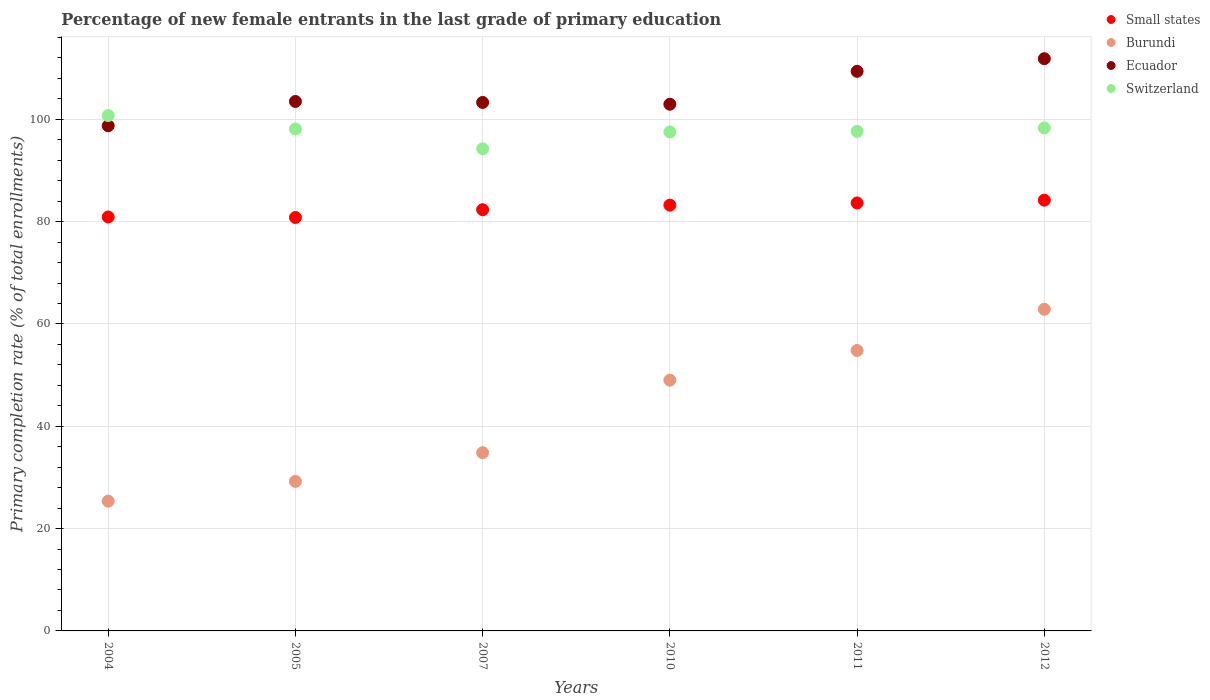How many different coloured dotlines are there?
Your answer should be very brief. 4. Is the number of dotlines equal to the number of legend labels?
Keep it short and to the point. Yes. What is the percentage of new female entrants in Ecuador in 2010?
Your answer should be very brief. 102.95. Across all years, what is the maximum percentage of new female entrants in Small states?
Your answer should be compact. 84.2. Across all years, what is the minimum percentage of new female entrants in Switzerland?
Make the answer very short. 94.25. In which year was the percentage of new female entrants in Ecuador maximum?
Offer a very short reply. 2012. What is the total percentage of new female entrants in Switzerland in the graph?
Offer a very short reply. 586.6. What is the difference between the percentage of new female entrants in Switzerland in 2004 and that in 2012?
Provide a short and direct response. 2.4. What is the difference between the percentage of new female entrants in Burundi in 2004 and the percentage of new female entrants in Switzerland in 2007?
Offer a terse response. -68.88. What is the average percentage of new female entrants in Ecuador per year?
Your answer should be very brief. 104.95. In the year 2012, what is the difference between the percentage of new female entrants in Small states and percentage of new female entrants in Switzerland?
Provide a succinct answer. -14.13. In how many years, is the percentage of new female entrants in Burundi greater than 112 %?
Make the answer very short. 0. What is the ratio of the percentage of new female entrants in Ecuador in 2004 to that in 2007?
Your response must be concise. 0.96. Is the percentage of new female entrants in Small states in 2011 less than that in 2012?
Offer a terse response. Yes. Is the difference between the percentage of new female entrants in Small states in 2011 and 2012 greater than the difference between the percentage of new female entrants in Switzerland in 2011 and 2012?
Provide a succinct answer. Yes. What is the difference between the highest and the second highest percentage of new female entrants in Burundi?
Keep it short and to the point. 8.06. What is the difference between the highest and the lowest percentage of new female entrants in Ecuador?
Offer a terse response. 13.11. In how many years, is the percentage of new female entrants in Small states greater than the average percentage of new female entrants in Small states taken over all years?
Keep it short and to the point. 3. Is the sum of the percentage of new female entrants in Switzerland in 2004 and 2011 greater than the maximum percentage of new female entrants in Ecuador across all years?
Provide a succinct answer. Yes. Is it the case that in every year, the sum of the percentage of new female entrants in Switzerland and percentage of new female entrants in Ecuador  is greater than the sum of percentage of new female entrants in Small states and percentage of new female entrants in Burundi?
Provide a succinct answer. Yes. Is it the case that in every year, the sum of the percentage of new female entrants in Ecuador and percentage of new female entrants in Small states  is greater than the percentage of new female entrants in Switzerland?
Offer a very short reply. Yes. Does the percentage of new female entrants in Small states monotonically increase over the years?
Your response must be concise. No. Is the percentage of new female entrants in Ecuador strictly less than the percentage of new female entrants in Burundi over the years?
Give a very brief answer. No. How many dotlines are there?
Your answer should be very brief. 4. How many years are there in the graph?
Provide a short and direct response. 6. How many legend labels are there?
Your response must be concise. 4. How are the legend labels stacked?
Provide a succinct answer. Vertical. What is the title of the graph?
Keep it short and to the point. Percentage of new female entrants in the last grade of primary education. What is the label or title of the X-axis?
Offer a very short reply. Years. What is the label or title of the Y-axis?
Provide a short and direct response. Primary completion rate (% of total enrollments). What is the Primary completion rate (% of total enrollments) in Small states in 2004?
Give a very brief answer. 80.91. What is the Primary completion rate (% of total enrollments) in Burundi in 2004?
Make the answer very short. 25.37. What is the Primary completion rate (% of total enrollments) in Ecuador in 2004?
Provide a short and direct response. 98.74. What is the Primary completion rate (% of total enrollments) of Switzerland in 2004?
Keep it short and to the point. 100.73. What is the Primary completion rate (% of total enrollments) in Small states in 2005?
Ensure brevity in your answer.  80.81. What is the Primary completion rate (% of total enrollments) of Burundi in 2005?
Your answer should be compact. 29.23. What is the Primary completion rate (% of total enrollments) in Ecuador in 2005?
Your answer should be very brief. 103.5. What is the Primary completion rate (% of total enrollments) of Switzerland in 2005?
Make the answer very short. 98.11. What is the Primary completion rate (% of total enrollments) of Small states in 2007?
Make the answer very short. 82.34. What is the Primary completion rate (% of total enrollments) in Burundi in 2007?
Provide a succinct answer. 34.84. What is the Primary completion rate (% of total enrollments) in Ecuador in 2007?
Your response must be concise. 103.3. What is the Primary completion rate (% of total enrollments) of Switzerland in 2007?
Offer a terse response. 94.25. What is the Primary completion rate (% of total enrollments) in Small states in 2010?
Keep it short and to the point. 83.23. What is the Primary completion rate (% of total enrollments) in Burundi in 2010?
Your answer should be very brief. 49.01. What is the Primary completion rate (% of total enrollments) in Ecuador in 2010?
Provide a succinct answer. 102.95. What is the Primary completion rate (% of total enrollments) in Switzerland in 2010?
Offer a very short reply. 97.54. What is the Primary completion rate (% of total enrollments) in Small states in 2011?
Offer a terse response. 83.66. What is the Primary completion rate (% of total enrollments) of Burundi in 2011?
Your response must be concise. 54.82. What is the Primary completion rate (% of total enrollments) of Ecuador in 2011?
Your answer should be very brief. 109.38. What is the Primary completion rate (% of total enrollments) of Switzerland in 2011?
Make the answer very short. 97.64. What is the Primary completion rate (% of total enrollments) in Small states in 2012?
Your answer should be very brief. 84.2. What is the Primary completion rate (% of total enrollments) of Burundi in 2012?
Keep it short and to the point. 62.88. What is the Primary completion rate (% of total enrollments) in Ecuador in 2012?
Offer a very short reply. 111.85. What is the Primary completion rate (% of total enrollments) in Switzerland in 2012?
Ensure brevity in your answer.  98.33. Across all years, what is the maximum Primary completion rate (% of total enrollments) in Small states?
Your answer should be compact. 84.2. Across all years, what is the maximum Primary completion rate (% of total enrollments) in Burundi?
Offer a very short reply. 62.88. Across all years, what is the maximum Primary completion rate (% of total enrollments) of Ecuador?
Make the answer very short. 111.85. Across all years, what is the maximum Primary completion rate (% of total enrollments) in Switzerland?
Offer a very short reply. 100.73. Across all years, what is the minimum Primary completion rate (% of total enrollments) of Small states?
Your answer should be compact. 80.81. Across all years, what is the minimum Primary completion rate (% of total enrollments) in Burundi?
Offer a terse response. 25.37. Across all years, what is the minimum Primary completion rate (% of total enrollments) of Ecuador?
Ensure brevity in your answer.  98.74. Across all years, what is the minimum Primary completion rate (% of total enrollments) in Switzerland?
Offer a very short reply. 94.25. What is the total Primary completion rate (% of total enrollments) of Small states in the graph?
Ensure brevity in your answer.  495.15. What is the total Primary completion rate (% of total enrollments) of Burundi in the graph?
Ensure brevity in your answer.  256.14. What is the total Primary completion rate (% of total enrollments) in Ecuador in the graph?
Ensure brevity in your answer.  629.73. What is the total Primary completion rate (% of total enrollments) of Switzerland in the graph?
Provide a succinct answer. 586.6. What is the difference between the Primary completion rate (% of total enrollments) of Small states in 2004 and that in 2005?
Provide a short and direct response. 0.1. What is the difference between the Primary completion rate (% of total enrollments) in Burundi in 2004 and that in 2005?
Provide a short and direct response. -3.87. What is the difference between the Primary completion rate (% of total enrollments) of Ecuador in 2004 and that in 2005?
Ensure brevity in your answer.  -4.75. What is the difference between the Primary completion rate (% of total enrollments) in Switzerland in 2004 and that in 2005?
Offer a terse response. 2.62. What is the difference between the Primary completion rate (% of total enrollments) of Small states in 2004 and that in 2007?
Provide a short and direct response. -1.42. What is the difference between the Primary completion rate (% of total enrollments) of Burundi in 2004 and that in 2007?
Offer a terse response. -9.47. What is the difference between the Primary completion rate (% of total enrollments) in Ecuador in 2004 and that in 2007?
Offer a very short reply. -4.56. What is the difference between the Primary completion rate (% of total enrollments) of Switzerland in 2004 and that in 2007?
Your response must be concise. 6.49. What is the difference between the Primary completion rate (% of total enrollments) of Small states in 2004 and that in 2010?
Ensure brevity in your answer.  -2.31. What is the difference between the Primary completion rate (% of total enrollments) of Burundi in 2004 and that in 2010?
Keep it short and to the point. -23.65. What is the difference between the Primary completion rate (% of total enrollments) in Ecuador in 2004 and that in 2010?
Your response must be concise. -4.21. What is the difference between the Primary completion rate (% of total enrollments) of Switzerland in 2004 and that in 2010?
Offer a terse response. 3.19. What is the difference between the Primary completion rate (% of total enrollments) in Small states in 2004 and that in 2011?
Your answer should be very brief. -2.74. What is the difference between the Primary completion rate (% of total enrollments) of Burundi in 2004 and that in 2011?
Make the answer very short. -29.45. What is the difference between the Primary completion rate (% of total enrollments) in Ecuador in 2004 and that in 2011?
Provide a short and direct response. -10.64. What is the difference between the Primary completion rate (% of total enrollments) of Switzerland in 2004 and that in 2011?
Keep it short and to the point. 3.09. What is the difference between the Primary completion rate (% of total enrollments) of Small states in 2004 and that in 2012?
Give a very brief answer. -3.29. What is the difference between the Primary completion rate (% of total enrollments) of Burundi in 2004 and that in 2012?
Provide a short and direct response. -37.51. What is the difference between the Primary completion rate (% of total enrollments) in Ecuador in 2004 and that in 2012?
Provide a succinct answer. -13.11. What is the difference between the Primary completion rate (% of total enrollments) in Switzerland in 2004 and that in 2012?
Offer a very short reply. 2.4. What is the difference between the Primary completion rate (% of total enrollments) in Small states in 2005 and that in 2007?
Your answer should be compact. -1.52. What is the difference between the Primary completion rate (% of total enrollments) in Burundi in 2005 and that in 2007?
Keep it short and to the point. -5.61. What is the difference between the Primary completion rate (% of total enrollments) of Ecuador in 2005 and that in 2007?
Offer a terse response. 0.19. What is the difference between the Primary completion rate (% of total enrollments) in Switzerland in 2005 and that in 2007?
Provide a succinct answer. 3.86. What is the difference between the Primary completion rate (% of total enrollments) of Small states in 2005 and that in 2010?
Give a very brief answer. -2.41. What is the difference between the Primary completion rate (% of total enrollments) in Burundi in 2005 and that in 2010?
Make the answer very short. -19.78. What is the difference between the Primary completion rate (% of total enrollments) of Ecuador in 2005 and that in 2010?
Provide a short and direct response. 0.54. What is the difference between the Primary completion rate (% of total enrollments) in Switzerland in 2005 and that in 2010?
Give a very brief answer. 0.57. What is the difference between the Primary completion rate (% of total enrollments) in Small states in 2005 and that in 2011?
Provide a succinct answer. -2.84. What is the difference between the Primary completion rate (% of total enrollments) in Burundi in 2005 and that in 2011?
Offer a terse response. -25.58. What is the difference between the Primary completion rate (% of total enrollments) in Ecuador in 2005 and that in 2011?
Provide a succinct answer. -5.89. What is the difference between the Primary completion rate (% of total enrollments) of Switzerland in 2005 and that in 2011?
Provide a succinct answer. 0.46. What is the difference between the Primary completion rate (% of total enrollments) of Small states in 2005 and that in 2012?
Your response must be concise. -3.39. What is the difference between the Primary completion rate (% of total enrollments) in Burundi in 2005 and that in 2012?
Keep it short and to the point. -33.64. What is the difference between the Primary completion rate (% of total enrollments) of Ecuador in 2005 and that in 2012?
Keep it short and to the point. -8.36. What is the difference between the Primary completion rate (% of total enrollments) in Switzerland in 2005 and that in 2012?
Your response must be concise. -0.22. What is the difference between the Primary completion rate (% of total enrollments) in Small states in 2007 and that in 2010?
Give a very brief answer. -0.89. What is the difference between the Primary completion rate (% of total enrollments) of Burundi in 2007 and that in 2010?
Make the answer very short. -14.17. What is the difference between the Primary completion rate (% of total enrollments) of Ecuador in 2007 and that in 2010?
Ensure brevity in your answer.  0.35. What is the difference between the Primary completion rate (% of total enrollments) in Switzerland in 2007 and that in 2010?
Your answer should be compact. -3.29. What is the difference between the Primary completion rate (% of total enrollments) in Small states in 2007 and that in 2011?
Ensure brevity in your answer.  -1.32. What is the difference between the Primary completion rate (% of total enrollments) of Burundi in 2007 and that in 2011?
Provide a short and direct response. -19.98. What is the difference between the Primary completion rate (% of total enrollments) in Ecuador in 2007 and that in 2011?
Offer a terse response. -6.08. What is the difference between the Primary completion rate (% of total enrollments) in Switzerland in 2007 and that in 2011?
Your response must be concise. -3.4. What is the difference between the Primary completion rate (% of total enrollments) of Small states in 2007 and that in 2012?
Offer a terse response. -1.87. What is the difference between the Primary completion rate (% of total enrollments) in Burundi in 2007 and that in 2012?
Your answer should be very brief. -28.04. What is the difference between the Primary completion rate (% of total enrollments) of Ecuador in 2007 and that in 2012?
Your answer should be very brief. -8.55. What is the difference between the Primary completion rate (% of total enrollments) of Switzerland in 2007 and that in 2012?
Give a very brief answer. -4.08. What is the difference between the Primary completion rate (% of total enrollments) of Small states in 2010 and that in 2011?
Your response must be concise. -0.43. What is the difference between the Primary completion rate (% of total enrollments) of Burundi in 2010 and that in 2011?
Give a very brief answer. -5.8. What is the difference between the Primary completion rate (% of total enrollments) of Ecuador in 2010 and that in 2011?
Your answer should be very brief. -6.43. What is the difference between the Primary completion rate (% of total enrollments) of Switzerland in 2010 and that in 2011?
Provide a succinct answer. -0.11. What is the difference between the Primary completion rate (% of total enrollments) of Small states in 2010 and that in 2012?
Keep it short and to the point. -0.98. What is the difference between the Primary completion rate (% of total enrollments) of Burundi in 2010 and that in 2012?
Your response must be concise. -13.86. What is the difference between the Primary completion rate (% of total enrollments) in Ecuador in 2010 and that in 2012?
Your answer should be compact. -8.9. What is the difference between the Primary completion rate (% of total enrollments) of Switzerland in 2010 and that in 2012?
Make the answer very short. -0.79. What is the difference between the Primary completion rate (% of total enrollments) of Small states in 2011 and that in 2012?
Your answer should be very brief. -0.55. What is the difference between the Primary completion rate (% of total enrollments) in Burundi in 2011 and that in 2012?
Your response must be concise. -8.06. What is the difference between the Primary completion rate (% of total enrollments) in Ecuador in 2011 and that in 2012?
Your answer should be compact. -2.47. What is the difference between the Primary completion rate (% of total enrollments) of Switzerland in 2011 and that in 2012?
Provide a succinct answer. -0.69. What is the difference between the Primary completion rate (% of total enrollments) in Small states in 2004 and the Primary completion rate (% of total enrollments) in Burundi in 2005?
Give a very brief answer. 51.68. What is the difference between the Primary completion rate (% of total enrollments) in Small states in 2004 and the Primary completion rate (% of total enrollments) in Ecuador in 2005?
Provide a short and direct response. -22.58. What is the difference between the Primary completion rate (% of total enrollments) of Small states in 2004 and the Primary completion rate (% of total enrollments) of Switzerland in 2005?
Offer a terse response. -17.2. What is the difference between the Primary completion rate (% of total enrollments) of Burundi in 2004 and the Primary completion rate (% of total enrollments) of Ecuador in 2005?
Your answer should be compact. -78.13. What is the difference between the Primary completion rate (% of total enrollments) of Burundi in 2004 and the Primary completion rate (% of total enrollments) of Switzerland in 2005?
Make the answer very short. -72.74. What is the difference between the Primary completion rate (% of total enrollments) of Ecuador in 2004 and the Primary completion rate (% of total enrollments) of Switzerland in 2005?
Provide a succinct answer. 0.64. What is the difference between the Primary completion rate (% of total enrollments) in Small states in 2004 and the Primary completion rate (% of total enrollments) in Burundi in 2007?
Offer a terse response. 46.07. What is the difference between the Primary completion rate (% of total enrollments) in Small states in 2004 and the Primary completion rate (% of total enrollments) in Ecuador in 2007?
Offer a very short reply. -22.39. What is the difference between the Primary completion rate (% of total enrollments) of Small states in 2004 and the Primary completion rate (% of total enrollments) of Switzerland in 2007?
Offer a very short reply. -13.33. What is the difference between the Primary completion rate (% of total enrollments) of Burundi in 2004 and the Primary completion rate (% of total enrollments) of Ecuador in 2007?
Provide a short and direct response. -77.94. What is the difference between the Primary completion rate (% of total enrollments) of Burundi in 2004 and the Primary completion rate (% of total enrollments) of Switzerland in 2007?
Provide a succinct answer. -68.88. What is the difference between the Primary completion rate (% of total enrollments) of Ecuador in 2004 and the Primary completion rate (% of total enrollments) of Switzerland in 2007?
Offer a terse response. 4.5. What is the difference between the Primary completion rate (% of total enrollments) in Small states in 2004 and the Primary completion rate (% of total enrollments) in Burundi in 2010?
Ensure brevity in your answer.  31.9. What is the difference between the Primary completion rate (% of total enrollments) of Small states in 2004 and the Primary completion rate (% of total enrollments) of Ecuador in 2010?
Make the answer very short. -22.04. What is the difference between the Primary completion rate (% of total enrollments) of Small states in 2004 and the Primary completion rate (% of total enrollments) of Switzerland in 2010?
Offer a very short reply. -16.63. What is the difference between the Primary completion rate (% of total enrollments) in Burundi in 2004 and the Primary completion rate (% of total enrollments) in Ecuador in 2010?
Keep it short and to the point. -77.59. What is the difference between the Primary completion rate (% of total enrollments) of Burundi in 2004 and the Primary completion rate (% of total enrollments) of Switzerland in 2010?
Offer a very short reply. -72.17. What is the difference between the Primary completion rate (% of total enrollments) in Ecuador in 2004 and the Primary completion rate (% of total enrollments) in Switzerland in 2010?
Offer a very short reply. 1.2. What is the difference between the Primary completion rate (% of total enrollments) of Small states in 2004 and the Primary completion rate (% of total enrollments) of Burundi in 2011?
Provide a short and direct response. 26.1. What is the difference between the Primary completion rate (% of total enrollments) of Small states in 2004 and the Primary completion rate (% of total enrollments) of Ecuador in 2011?
Offer a terse response. -28.47. What is the difference between the Primary completion rate (% of total enrollments) in Small states in 2004 and the Primary completion rate (% of total enrollments) in Switzerland in 2011?
Ensure brevity in your answer.  -16.73. What is the difference between the Primary completion rate (% of total enrollments) of Burundi in 2004 and the Primary completion rate (% of total enrollments) of Ecuador in 2011?
Your response must be concise. -84.02. What is the difference between the Primary completion rate (% of total enrollments) in Burundi in 2004 and the Primary completion rate (% of total enrollments) in Switzerland in 2011?
Offer a very short reply. -72.28. What is the difference between the Primary completion rate (% of total enrollments) of Ecuador in 2004 and the Primary completion rate (% of total enrollments) of Switzerland in 2011?
Ensure brevity in your answer.  1.1. What is the difference between the Primary completion rate (% of total enrollments) in Small states in 2004 and the Primary completion rate (% of total enrollments) in Burundi in 2012?
Your answer should be very brief. 18.04. What is the difference between the Primary completion rate (% of total enrollments) of Small states in 2004 and the Primary completion rate (% of total enrollments) of Ecuador in 2012?
Your answer should be very brief. -30.94. What is the difference between the Primary completion rate (% of total enrollments) of Small states in 2004 and the Primary completion rate (% of total enrollments) of Switzerland in 2012?
Provide a short and direct response. -17.42. What is the difference between the Primary completion rate (% of total enrollments) in Burundi in 2004 and the Primary completion rate (% of total enrollments) in Ecuador in 2012?
Provide a succinct answer. -86.49. What is the difference between the Primary completion rate (% of total enrollments) in Burundi in 2004 and the Primary completion rate (% of total enrollments) in Switzerland in 2012?
Your response must be concise. -72.96. What is the difference between the Primary completion rate (% of total enrollments) in Ecuador in 2004 and the Primary completion rate (% of total enrollments) in Switzerland in 2012?
Offer a terse response. 0.41. What is the difference between the Primary completion rate (% of total enrollments) of Small states in 2005 and the Primary completion rate (% of total enrollments) of Burundi in 2007?
Offer a terse response. 45.97. What is the difference between the Primary completion rate (% of total enrollments) of Small states in 2005 and the Primary completion rate (% of total enrollments) of Ecuador in 2007?
Your response must be concise. -22.49. What is the difference between the Primary completion rate (% of total enrollments) in Small states in 2005 and the Primary completion rate (% of total enrollments) in Switzerland in 2007?
Ensure brevity in your answer.  -13.43. What is the difference between the Primary completion rate (% of total enrollments) in Burundi in 2005 and the Primary completion rate (% of total enrollments) in Ecuador in 2007?
Your answer should be very brief. -74.07. What is the difference between the Primary completion rate (% of total enrollments) of Burundi in 2005 and the Primary completion rate (% of total enrollments) of Switzerland in 2007?
Your answer should be very brief. -65.01. What is the difference between the Primary completion rate (% of total enrollments) of Ecuador in 2005 and the Primary completion rate (% of total enrollments) of Switzerland in 2007?
Provide a succinct answer. 9.25. What is the difference between the Primary completion rate (% of total enrollments) in Small states in 2005 and the Primary completion rate (% of total enrollments) in Burundi in 2010?
Your answer should be compact. 31.8. What is the difference between the Primary completion rate (% of total enrollments) in Small states in 2005 and the Primary completion rate (% of total enrollments) in Ecuador in 2010?
Make the answer very short. -22.14. What is the difference between the Primary completion rate (% of total enrollments) in Small states in 2005 and the Primary completion rate (% of total enrollments) in Switzerland in 2010?
Provide a succinct answer. -16.73. What is the difference between the Primary completion rate (% of total enrollments) in Burundi in 2005 and the Primary completion rate (% of total enrollments) in Ecuador in 2010?
Offer a terse response. -73.72. What is the difference between the Primary completion rate (% of total enrollments) of Burundi in 2005 and the Primary completion rate (% of total enrollments) of Switzerland in 2010?
Provide a short and direct response. -68.31. What is the difference between the Primary completion rate (% of total enrollments) of Ecuador in 2005 and the Primary completion rate (% of total enrollments) of Switzerland in 2010?
Offer a terse response. 5.96. What is the difference between the Primary completion rate (% of total enrollments) of Small states in 2005 and the Primary completion rate (% of total enrollments) of Burundi in 2011?
Your response must be concise. 26. What is the difference between the Primary completion rate (% of total enrollments) in Small states in 2005 and the Primary completion rate (% of total enrollments) in Ecuador in 2011?
Offer a terse response. -28.57. What is the difference between the Primary completion rate (% of total enrollments) in Small states in 2005 and the Primary completion rate (% of total enrollments) in Switzerland in 2011?
Offer a terse response. -16.83. What is the difference between the Primary completion rate (% of total enrollments) in Burundi in 2005 and the Primary completion rate (% of total enrollments) in Ecuador in 2011?
Make the answer very short. -80.15. What is the difference between the Primary completion rate (% of total enrollments) in Burundi in 2005 and the Primary completion rate (% of total enrollments) in Switzerland in 2011?
Provide a short and direct response. -68.41. What is the difference between the Primary completion rate (% of total enrollments) in Ecuador in 2005 and the Primary completion rate (% of total enrollments) in Switzerland in 2011?
Offer a very short reply. 5.85. What is the difference between the Primary completion rate (% of total enrollments) of Small states in 2005 and the Primary completion rate (% of total enrollments) of Burundi in 2012?
Keep it short and to the point. 17.94. What is the difference between the Primary completion rate (% of total enrollments) of Small states in 2005 and the Primary completion rate (% of total enrollments) of Ecuador in 2012?
Make the answer very short. -31.04. What is the difference between the Primary completion rate (% of total enrollments) of Small states in 2005 and the Primary completion rate (% of total enrollments) of Switzerland in 2012?
Your answer should be very brief. -17.52. What is the difference between the Primary completion rate (% of total enrollments) in Burundi in 2005 and the Primary completion rate (% of total enrollments) in Ecuador in 2012?
Ensure brevity in your answer.  -82.62. What is the difference between the Primary completion rate (% of total enrollments) of Burundi in 2005 and the Primary completion rate (% of total enrollments) of Switzerland in 2012?
Offer a terse response. -69.1. What is the difference between the Primary completion rate (% of total enrollments) in Ecuador in 2005 and the Primary completion rate (% of total enrollments) in Switzerland in 2012?
Keep it short and to the point. 5.17. What is the difference between the Primary completion rate (% of total enrollments) in Small states in 2007 and the Primary completion rate (% of total enrollments) in Burundi in 2010?
Provide a short and direct response. 33.32. What is the difference between the Primary completion rate (% of total enrollments) in Small states in 2007 and the Primary completion rate (% of total enrollments) in Ecuador in 2010?
Provide a succinct answer. -20.62. What is the difference between the Primary completion rate (% of total enrollments) in Small states in 2007 and the Primary completion rate (% of total enrollments) in Switzerland in 2010?
Your answer should be very brief. -15.2. What is the difference between the Primary completion rate (% of total enrollments) of Burundi in 2007 and the Primary completion rate (% of total enrollments) of Ecuador in 2010?
Offer a very short reply. -68.11. What is the difference between the Primary completion rate (% of total enrollments) of Burundi in 2007 and the Primary completion rate (% of total enrollments) of Switzerland in 2010?
Provide a short and direct response. -62.7. What is the difference between the Primary completion rate (% of total enrollments) in Ecuador in 2007 and the Primary completion rate (% of total enrollments) in Switzerland in 2010?
Ensure brevity in your answer.  5.76. What is the difference between the Primary completion rate (% of total enrollments) in Small states in 2007 and the Primary completion rate (% of total enrollments) in Burundi in 2011?
Offer a terse response. 27.52. What is the difference between the Primary completion rate (% of total enrollments) of Small states in 2007 and the Primary completion rate (% of total enrollments) of Ecuador in 2011?
Make the answer very short. -27.05. What is the difference between the Primary completion rate (% of total enrollments) in Small states in 2007 and the Primary completion rate (% of total enrollments) in Switzerland in 2011?
Your response must be concise. -15.31. What is the difference between the Primary completion rate (% of total enrollments) of Burundi in 2007 and the Primary completion rate (% of total enrollments) of Ecuador in 2011?
Offer a terse response. -74.54. What is the difference between the Primary completion rate (% of total enrollments) in Burundi in 2007 and the Primary completion rate (% of total enrollments) in Switzerland in 2011?
Offer a very short reply. -62.8. What is the difference between the Primary completion rate (% of total enrollments) in Ecuador in 2007 and the Primary completion rate (% of total enrollments) in Switzerland in 2011?
Offer a terse response. 5.66. What is the difference between the Primary completion rate (% of total enrollments) in Small states in 2007 and the Primary completion rate (% of total enrollments) in Burundi in 2012?
Provide a short and direct response. 19.46. What is the difference between the Primary completion rate (% of total enrollments) in Small states in 2007 and the Primary completion rate (% of total enrollments) in Ecuador in 2012?
Make the answer very short. -29.52. What is the difference between the Primary completion rate (% of total enrollments) of Small states in 2007 and the Primary completion rate (% of total enrollments) of Switzerland in 2012?
Your response must be concise. -15.99. What is the difference between the Primary completion rate (% of total enrollments) in Burundi in 2007 and the Primary completion rate (% of total enrollments) in Ecuador in 2012?
Give a very brief answer. -77.01. What is the difference between the Primary completion rate (% of total enrollments) in Burundi in 2007 and the Primary completion rate (% of total enrollments) in Switzerland in 2012?
Your answer should be compact. -63.49. What is the difference between the Primary completion rate (% of total enrollments) of Ecuador in 2007 and the Primary completion rate (% of total enrollments) of Switzerland in 2012?
Your answer should be very brief. 4.97. What is the difference between the Primary completion rate (% of total enrollments) in Small states in 2010 and the Primary completion rate (% of total enrollments) in Burundi in 2011?
Give a very brief answer. 28.41. What is the difference between the Primary completion rate (% of total enrollments) in Small states in 2010 and the Primary completion rate (% of total enrollments) in Ecuador in 2011?
Your answer should be very brief. -26.16. What is the difference between the Primary completion rate (% of total enrollments) in Small states in 2010 and the Primary completion rate (% of total enrollments) in Switzerland in 2011?
Give a very brief answer. -14.42. What is the difference between the Primary completion rate (% of total enrollments) in Burundi in 2010 and the Primary completion rate (% of total enrollments) in Ecuador in 2011?
Offer a terse response. -60.37. What is the difference between the Primary completion rate (% of total enrollments) of Burundi in 2010 and the Primary completion rate (% of total enrollments) of Switzerland in 2011?
Give a very brief answer. -48.63. What is the difference between the Primary completion rate (% of total enrollments) of Ecuador in 2010 and the Primary completion rate (% of total enrollments) of Switzerland in 2011?
Your answer should be very brief. 5.31. What is the difference between the Primary completion rate (% of total enrollments) of Small states in 2010 and the Primary completion rate (% of total enrollments) of Burundi in 2012?
Offer a very short reply. 20.35. What is the difference between the Primary completion rate (% of total enrollments) in Small states in 2010 and the Primary completion rate (% of total enrollments) in Ecuador in 2012?
Provide a succinct answer. -28.63. What is the difference between the Primary completion rate (% of total enrollments) in Small states in 2010 and the Primary completion rate (% of total enrollments) in Switzerland in 2012?
Offer a terse response. -15.1. What is the difference between the Primary completion rate (% of total enrollments) of Burundi in 2010 and the Primary completion rate (% of total enrollments) of Ecuador in 2012?
Provide a short and direct response. -62.84. What is the difference between the Primary completion rate (% of total enrollments) in Burundi in 2010 and the Primary completion rate (% of total enrollments) in Switzerland in 2012?
Give a very brief answer. -49.32. What is the difference between the Primary completion rate (% of total enrollments) of Ecuador in 2010 and the Primary completion rate (% of total enrollments) of Switzerland in 2012?
Make the answer very short. 4.62. What is the difference between the Primary completion rate (% of total enrollments) in Small states in 2011 and the Primary completion rate (% of total enrollments) in Burundi in 2012?
Ensure brevity in your answer.  20.78. What is the difference between the Primary completion rate (% of total enrollments) of Small states in 2011 and the Primary completion rate (% of total enrollments) of Ecuador in 2012?
Offer a very short reply. -28.2. What is the difference between the Primary completion rate (% of total enrollments) in Small states in 2011 and the Primary completion rate (% of total enrollments) in Switzerland in 2012?
Your response must be concise. -14.67. What is the difference between the Primary completion rate (% of total enrollments) in Burundi in 2011 and the Primary completion rate (% of total enrollments) in Ecuador in 2012?
Ensure brevity in your answer.  -57.04. What is the difference between the Primary completion rate (% of total enrollments) in Burundi in 2011 and the Primary completion rate (% of total enrollments) in Switzerland in 2012?
Your answer should be compact. -43.51. What is the difference between the Primary completion rate (% of total enrollments) in Ecuador in 2011 and the Primary completion rate (% of total enrollments) in Switzerland in 2012?
Offer a very short reply. 11.05. What is the average Primary completion rate (% of total enrollments) of Small states per year?
Your answer should be very brief. 82.52. What is the average Primary completion rate (% of total enrollments) of Burundi per year?
Offer a very short reply. 42.69. What is the average Primary completion rate (% of total enrollments) in Ecuador per year?
Your response must be concise. 104.95. What is the average Primary completion rate (% of total enrollments) of Switzerland per year?
Give a very brief answer. 97.77. In the year 2004, what is the difference between the Primary completion rate (% of total enrollments) of Small states and Primary completion rate (% of total enrollments) of Burundi?
Your answer should be compact. 55.55. In the year 2004, what is the difference between the Primary completion rate (% of total enrollments) in Small states and Primary completion rate (% of total enrollments) in Ecuador?
Your answer should be very brief. -17.83. In the year 2004, what is the difference between the Primary completion rate (% of total enrollments) of Small states and Primary completion rate (% of total enrollments) of Switzerland?
Your answer should be compact. -19.82. In the year 2004, what is the difference between the Primary completion rate (% of total enrollments) in Burundi and Primary completion rate (% of total enrollments) in Ecuador?
Offer a very short reply. -73.38. In the year 2004, what is the difference between the Primary completion rate (% of total enrollments) of Burundi and Primary completion rate (% of total enrollments) of Switzerland?
Your answer should be compact. -75.37. In the year 2004, what is the difference between the Primary completion rate (% of total enrollments) in Ecuador and Primary completion rate (% of total enrollments) in Switzerland?
Keep it short and to the point. -1.99. In the year 2005, what is the difference between the Primary completion rate (% of total enrollments) in Small states and Primary completion rate (% of total enrollments) in Burundi?
Provide a short and direct response. 51.58. In the year 2005, what is the difference between the Primary completion rate (% of total enrollments) of Small states and Primary completion rate (% of total enrollments) of Ecuador?
Provide a succinct answer. -22.68. In the year 2005, what is the difference between the Primary completion rate (% of total enrollments) of Small states and Primary completion rate (% of total enrollments) of Switzerland?
Your answer should be very brief. -17.29. In the year 2005, what is the difference between the Primary completion rate (% of total enrollments) of Burundi and Primary completion rate (% of total enrollments) of Ecuador?
Ensure brevity in your answer.  -74.26. In the year 2005, what is the difference between the Primary completion rate (% of total enrollments) of Burundi and Primary completion rate (% of total enrollments) of Switzerland?
Your answer should be compact. -68.88. In the year 2005, what is the difference between the Primary completion rate (% of total enrollments) in Ecuador and Primary completion rate (% of total enrollments) in Switzerland?
Offer a terse response. 5.39. In the year 2007, what is the difference between the Primary completion rate (% of total enrollments) of Small states and Primary completion rate (% of total enrollments) of Burundi?
Ensure brevity in your answer.  47.5. In the year 2007, what is the difference between the Primary completion rate (% of total enrollments) in Small states and Primary completion rate (% of total enrollments) in Ecuador?
Your response must be concise. -20.97. In the year 2007, what is the difference between the Primary completion rate (% of total enrollments) in Small states and Primary completion rate (% of total enrollments) in Switzerland?
Offer a terse response. -11.91. In the year 2007, what is the difference between the Primary completion rate (% of total enrollments) in Burundi and Primary completion rate (% of total enrollments) in Ecuador?
Provide a succinct answer. -68.46. In the year 2007, what is the difference between the Primary completion rate (% of total enrollments) of Burundi and Primary completion rate (% of total enrollments) of Switzerland?
Offer a very short reply. -59.4. In the year 2007, what is the difference between the Primary completion rate (% of total enrollments) of Ecuador and Primary completion rate (% of total enrollments) of Switzerland?
Ensure brevity in your answer.  9.06. In the year 2010, what is the difference between the Primary completion rate (% of total enrollments) of Small states and Primary completion rate (% of total enrollments) of Burundi?
Provide a short and direct response. 34.21. In the year 2010, what is the difference between the Primary completion rate (% of total enrollments) of Small states and Primary completion rate (% of total enrollments) of Ecuador?
Your response must be concise. -19.73. In the year 2010, what is the difference between the Primary completion rate (% of total enrollments) of Small states and Primary completion rate (% of total enrollments) of Switzerland?
Provide a short and direct response. -14.31. In the year 2010, what is the difference between the Primary completion rate (% of total enrollments) of Burundi and Primary completion rate (% of total enrollments) of Ecuador?
Ensure brevity in your answer.  -53.94. In the year 2010, what is the difference between the Primary completion rate (% of total enrollments) in Burundi and Primary completion rate (% of total enrollments) in Switzerland?
Your response must be concise. -48.53. In the year 2010, what is the difference between the Primary completion rate (% of total enrollments) in Ecuador and Primary completion rate (% of total enrollments) in Switzerland?
Make the answer very short. 5.42. In the year 2011, what is the difference between the Primary completion rate (% of total enrollments) in Small states and Primary completion rate (% of total enrollments) in Burundi?
Make the answer very short. 28.84. In the year 2011, what is the difference between the Primary completion rate (% of total enrollments) of Small states and Primary completion rate (% of total enrollments) of Ecuador?
Offer a very short reply. -25.73. In the year 2011, what is the difference between the Primary completion rate (% of total enrollments) of Small states and Primary completion rate (% of total enrollments) of Switzerland?
Provide a succinct answer. -13.99. In the year 2011, what is the difference between the Primary completion rate (% of total enrollments) in Burundi and Primary completion rate (% of total enrollments) in Ecuador?
Give a very brief answer. -54.57. In the year 2011, what is the difference between the Primary completion rate (% of total enrollments) in Burundi and Primary completion rate (% of total enrollments) in Switzerland?
Make the answer very short. -42.83. In the year 2011, what is the difference between the Primary completion rate (% of total enrollments) of Ecuador and Primary completion rate (% of total enrollments) of Switzerland?
Provide a short and direct response. 11.74. In the year 2012, what is the difference between the Primary completion rate (% of total enrollments) of Small states and Primary completion rate (% of total enrollments) of Burundi?
Provide a succinct answer. 21.33. In the year 2012, what is the difference between the Primary completion rate (% of total enrollments) in Small states and Primary completion rate (% of total enrollments) in Ecuador?
Give a very brief answer. -27.65. In the year 2012, what is the difference between the Primary completion rate (% of total enrollments) of Small states and Primary completion rate (% of total enrollments) of Switzerland?
Provide a succinct answer. -14.13. In the year 2012, what is the difference between the Primary completion rate (% of total enrollments) of Burundi and Primary completion rate (% of total enrollments) of Ecuador?
Give a very brief answer. -48.98. In the year 2012, what is the difference between the Primary completion rate (% of total enrollments) of Burundi and Primary completion rate (% of total enrollments) of Switzerland?
Keep it short and to the point. -35.45. In the year 2012, what is the difference between the Primary completion rate (% of total enrollments) in Ecuador and Primary completion rate (% of total enrollments) in Switzerland?
Provide a succinct answer. 13.52. What is the ratio of the Primary completion rate (% of total enrollments) in Small states in 2004 to that in 2005?
Give a very brief answer. 1. What is the ratio of the Primary completion rate (% of total enrollments) in Burundi in 2004 to that in 2005?
Offer a very short reply. 0.87. What is the ratio of the Primary completion rate (% of total enrollments) of Ecuador in 2004 to that in 2005?
Ensure brevity in your answer.  0.95. What is the ratio of the Primary completion rate (% of total enrollments) of Switzerland in 2004 to that in 2005?
Give a very brief answer. 1.03. What is the ratio of the Primary completion rate (% of total enrollments) in Small states in 2004 to that in 2007?
Ensure brevity in your answer.  0.98. What is the ratio of the Primary completion rate (% of total enrollments) of Burundi in 2004 to that in 2007?
Give a very brief answer. 0.73. What is the ratio of the Primary completion rate (% of total enrollments) in Ecuador in 2004 to that in 2007?
Your answer should be very brief. 0.96. What is the ratio of the Primary completion rate (% of total enrollments) in Switzerland in 2004 to that in 2007?
Give a very brief answer. 1.07. What is the ratio of the Primary completion rate (% of total enrollments) in Small states in 2004 to that in 2010?
Provide a short and direct response. 0.97. What is the ratio of the Primary completion rate (% of total enrollments) of Burundi in 2004 to that in 2010?
Offer a very short reply. 0.52. What is the ratio of the Primary completion rate (% of total enrollments) in Ecuador in 2004 to that in 2010?
Your answer should be compact. 0.96. What is the ratio of the Primary completion rate (% of total enrollments) of Switzerland in 2004 to that in 2010?
Your answer should be very brief. 1.03. What is the ratio of the Primary completion rate (% of total enrollments) of Small states in 2004 to that in 2011?
Offer a very short reply. 0.97. What is the ratio of the Primary completion rate (% of total enrollments) in Burundi in 2004 to that in 2011?
Keep it short and to the point. 0.46. What is the ratio of the Primary completion rate (% of total enrollments) in Ecuador in 2004 to that in 2011?
Provide a succinct answer. 0.9. What is the ratio of the Primary completion rate (% of total enrollments) of Switzerland in 2004 to that in 2011?
Offer a terse response. 1.03. What is the ratio of the Primary completion rate (% of total enrollments) in Small states in 2004 to that in 2012?
Provide a succinct answer. 0.96. What is the ratio of the Primary completion rate (% of total enrollments) of Burundi in 2004 to that in 2012?
Your answer should be compact. 0.4. What is the ratio of the Primary completion rate (% of total enrollments) of Ecuador in 2004 to that in 2012?
Make the answer very short. 0.88. What is the ratio of the Primary completion rate (% of total enrollments) of Switzerland in 2004 to that in 2012?
Your answer should be very brief. 1.02. What is the ratio of the Primary completion rate (% of total enrollments) of Small states in 2005 to that in 2007?
Give a very brief answer. 0.98. What is the ratio of the Primary completion rate (% of total enrollments) of Burundi in 2005 to that in 2007?
Offer a very short reply. 0.84. What is the ratio of the Primary completion rate (% of total enrollments) of Switzerland in 2005 to that in 2007?
Your answer should be very brief. 1.04. What is the ratio of the Primary completion rate (% of total enrollments) in Small states in 2005 to that in 2010?
Ensure brevity in your answer.  0.97. What is the ratio of the Primary completion rate (% of total enrollments) in Burundi in 2005 to that in 2010?
Offer a very short reply. 0.6. What is the ratio of the Primary completion rate (% of total enrollments) of Switzerland in 2005 to that in 2010?
Make the answer very short. 1.01. What is the ratio of the Primary completion rate (% of total enrollments) in Burundi in 2005 to that in 2011?
Keep it short and to the point. 0.53. What is the ratio of the Primary completion rate (% of total enrollments) of Ecuador in 2005 to that in 2011?
Ensure brevity in your answer.  0.95. What is the ratio of the Primary completion rate (% of total enrollments) of Small states in 2005 to that in 2012?
Your response must be concise. 0.96. What is the ratio of the Primary completion rate (% of total enrollments) of Burundi in 2005 to that in 2012?
Make the answer very short. 0.46. What is the ratio of the Primary completion rate (% of total enrollments) of Ecuador in 2005 to that in 2012?
Offer a terse response. 0.93. What is the ratio of the Primary completion rate (% of total enrollments) of Small states in 2007 to that in 2010?
Make the answer very short. 0.99. What is the ratio of the Primary completion rate (% of total enrollments) of Burundi in 2007 to that in 2010?
Provide a short and direct response. 0.71. What is the ratio of the Primary completion rate (% of total enrollments) in Ecuador in 2007 to that in 2010?
Your answer should be compact. 1. What is the ratio of the Primary completion rate (% of total enrollments) in Switzerland in 2007 to that in 2010?
Provide a short and direct response. 0.97. What is the ratio of the Primary completion rate (% of total enrollments) in Small states in 2007 to that in 2011?
Provide a short and direct response. 0.98. What is the ratio of the Primary completion rate (% of total enrollments) of Burundi in 2007 to that in 2011?
Make the answer very short. 0.64. What is the ratio of the Primary completion rate (% of total enrollments) in Ecuador in 2007 to that in 2011?
Your answer should be very brief. 0.94. What is the ratio of the Primary completion rate (% of total enrollments) of Switzerland in 2007 to that in 2011?
Make the answer very short. 0.97. What is the ratio of the Primary completion rate (% of total enrollments) of Small states in 2007 to that in 2012?
Make the answer very short. 0.98. What is the ratio of the Primary completion rate (% of total enrollments) in Burundi in 2007 to that in 2012?
Your answer should be compact. 0.55. What is the ratio of the Primary completion rate (% of total enrollments) in Ecuador in 2007 to that in 2012?
Ensure brevity in your answer.  0.92. What is the ratio of the Primary completion rate (% of total enrollments) of Switzerland in 2007 to that in 2012?
Your response must be concise. 0.96. What is the ratio of the Primary completion rate (% of total enrollments) in Small states in 2010 to that in 2011?
Your answer should be very brief. 0.99. What is the ratio of the Primary completion rate (% of total enrollments) of Burundi in 2010 to that in 2011?
Make the answer very short. 0.89. What is the ratio of the Primary completion rate (% of total enrollments) of Ecuador in 2010 to that in 2011?
Ensure brevity in your answer.  0.94. What is the ratio of the Primary completion rate (% of total enrollments) of Switzerland in 2010 to that in 2011?
Give a very brief answer. 1. What is the ratio of the Primary completion rate (% of total enrollments) of Small states in 2010 to that in 2012?
Keep it short and to the point. 0.99. What is the ratio of the Primary completion rate (% of total enrollments) of Burundi in 2010 to that in 2012?
Offer a very short reply. 0.78. What is the ratio of the Primary completion rate (% of total enrollments) in Ecuador in 2010 to that in 2012?
Offer a terse response. 0.92. What is the ratio of the Primary completion rate (% of total enrollments) of Switzerland in 2010 to that in 2012?
Keep it short and to the point. 0.99. What is the ratio of the Primary completion rate (% of total enrollments) in Burundi in 2011 to that in 2012?
Offer a very short reply. 0.87. What is the ratio of the Primary completion rate (% of total enrollments) in Ecuador in 2011 to that in 2012?
Offer a terse response. 0.98. What is the ratio of the Primary completion rate (% of total enrollments) in Switzerland in 2011 to that in 2012?
Keep it short and to the point. 0.99. What is the difference between the highest and the second highest Primary completion rate (% of total enrollments) of Small states?
Offer a very short reply. 0.55. What is the difference between the highest and the second highest Primary completion rate (% of total enrollments) of Burundi?
Ensure brevity in your answer.  8.06. What is the difference between the highest and the second highest Primary completion rate (% of total enrollments) of Ecuador?
Give a very brief answer. 2.47. What is the difference between the highest and the second highest Primary completion rate (% of total enrollments) of Switzerland?
Ensure brevity in your answer.  2.4. What is the difference between the highest and the lowest Primary completion rate (% of total enrollments) in Small states?
Give a very brief answer. 3.39. What is the difference between the highest and the lowest Primary completion rate (% of total enrollments) of Burundi?
Offer a terse response. 37.51. What is the difference between the highest and the lowest Primary completion rate (% of total enrollments) in Ecuador?
Make the answer very short. 13.11. What is the difference between the highest and the lowest Primary completion rate (% of total enrollments) in Switzerland?
Offer a terse response. 6.49. 